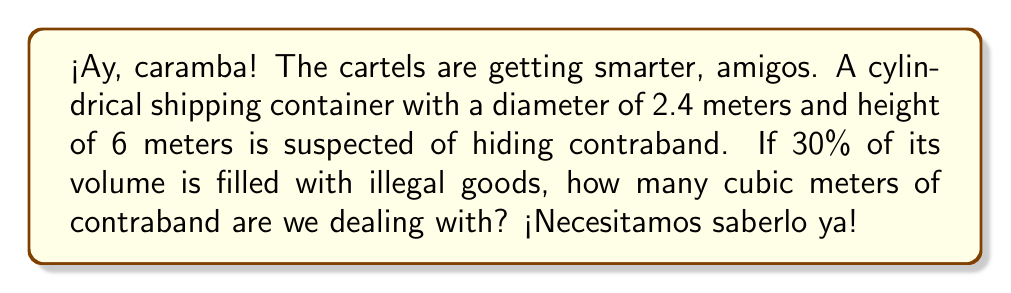Can you solve this math problem? Let's break this down, paso por paso:

1) First, we need to calculate the total volume of the cylindrical container. The formula for the volume of a cylinder is:

   $$V = \pi r^2 h$$

   Where $r$ is the radius and $h$ is the height.

2) The diameter is 2.4 meters, so the radius is half of that:
   
   $$r = 2.4 \div 2 = 1.2 \text{ meters}$$

3) Now we can plug in our values:

   $$V = \pi (1.2 \text{ m})^2 (6 \text{ m})$$

4) Let's calculate:

   $$V = \pi (1.44 \text{ m}^2) (6 \text{ m}) = 27.14 \text{ m}^3$$

5) But remember, only 30% of this volume is filled with contraband. To find 30% of 27.14, we multiply by 0.30:

   $$27.14 \text{ m}^3 \times 0.30 = 8.14 \text{ m}^3$$

¡Madre mía! That's a lot of contraband!
Answer: 8.14 m³ 